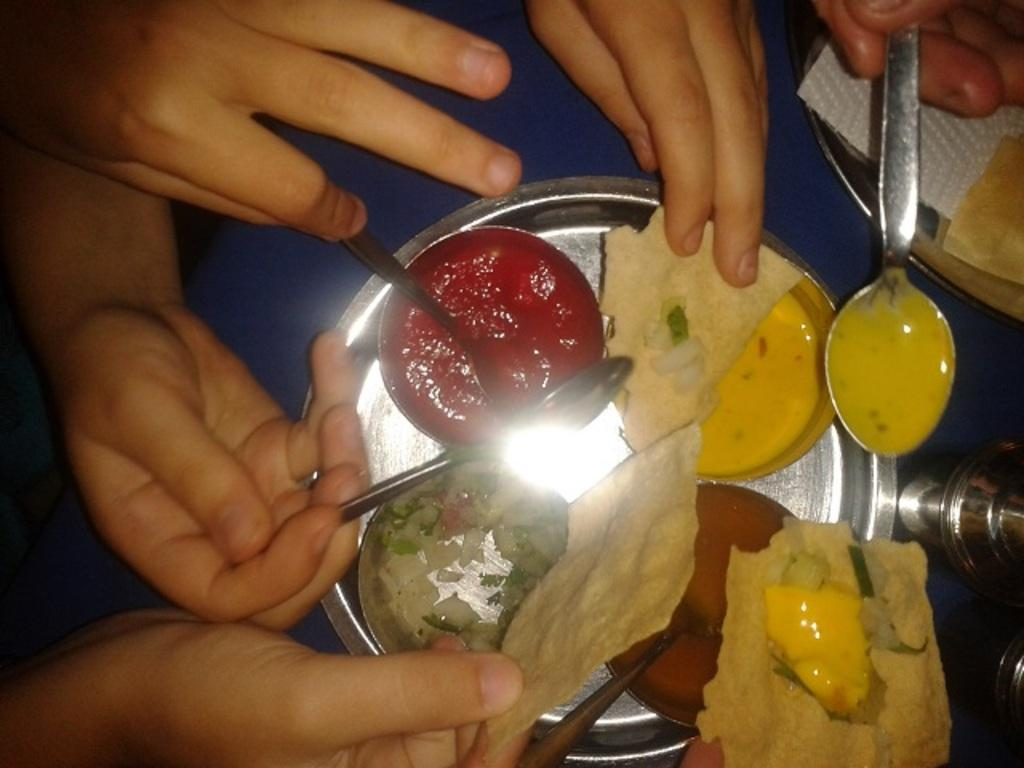What is the person in the image holding? The person is holding a spoon in the image. What can be seen on the table in the image? There are food items, tissue paper, steel plates, cucumber pieces, and other food items on the table in the image. Can you describe the food items on the table? The food items on the table include cucumber pieces and other unspecified food items. What type of shoes is the person wearing in the image? There is no information about shoes in the image, as the focus is on the person holding a spoon and the food items on the table. 